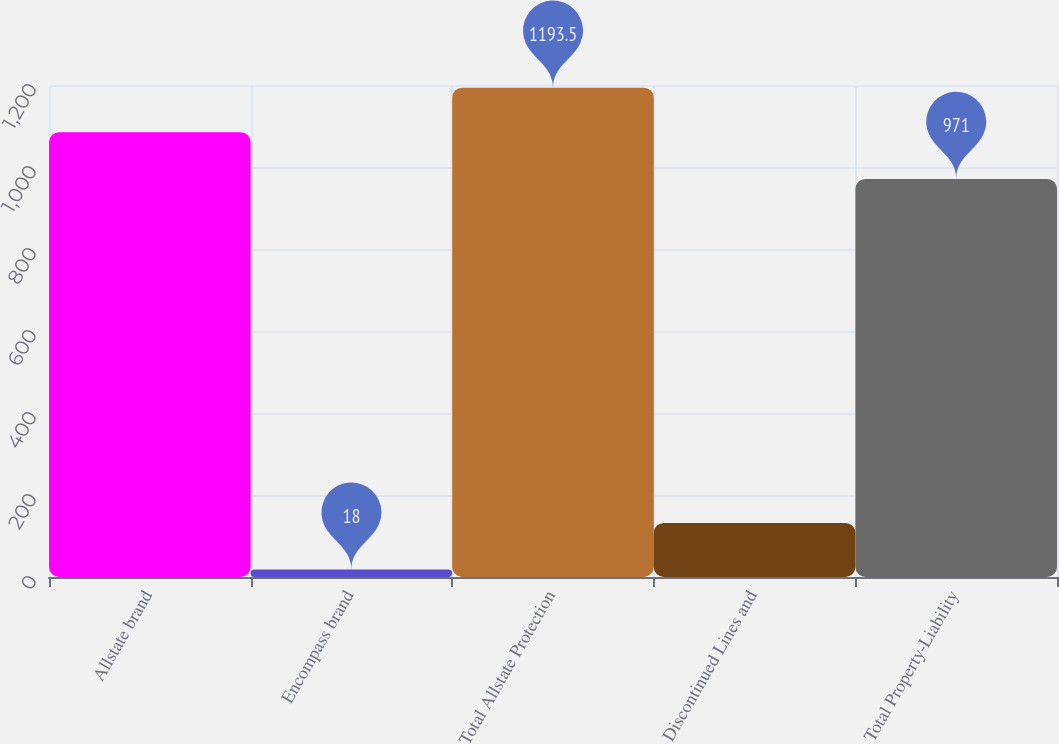Convert chart. <chart><loc_0><loc_0><loc_500><loc_500><bar_chart><fcel>Allstate brand<fcel>Encompass brand<fcel>Total Allstate Protection<fcel>Discontinued Lines and<fcel>Total Property-Liability<nl><fcel>1085<fcel>18<fcel>1193.5<fcel>132<fcel>971<nl></chart> 